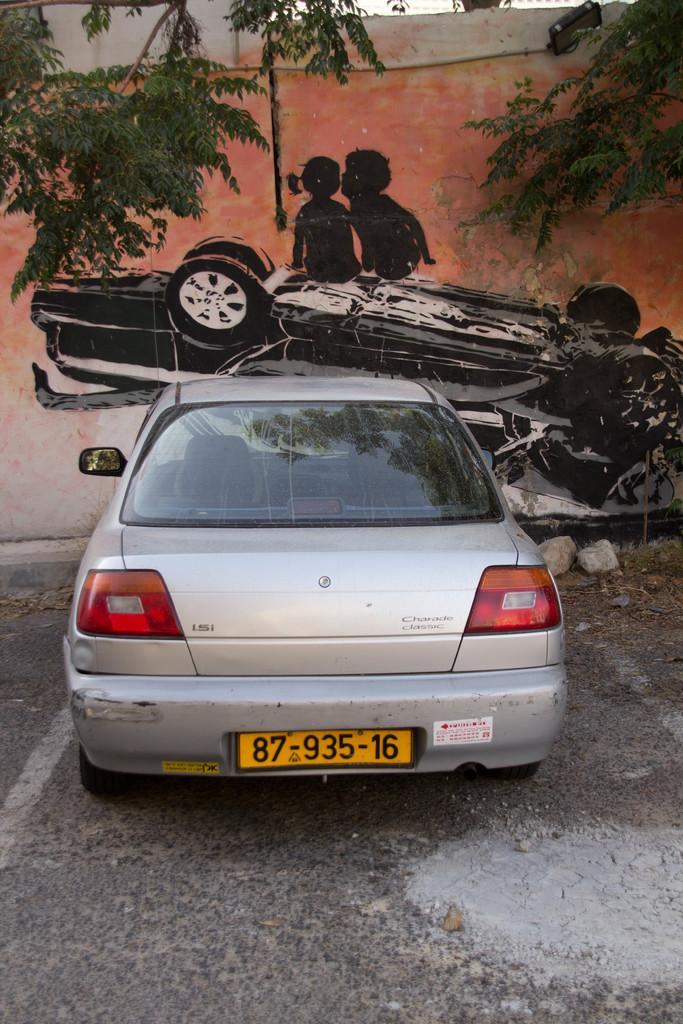Provide a one-sentence caption for the provided image. A Charade Classic car with a tag reading 87-935-16. 